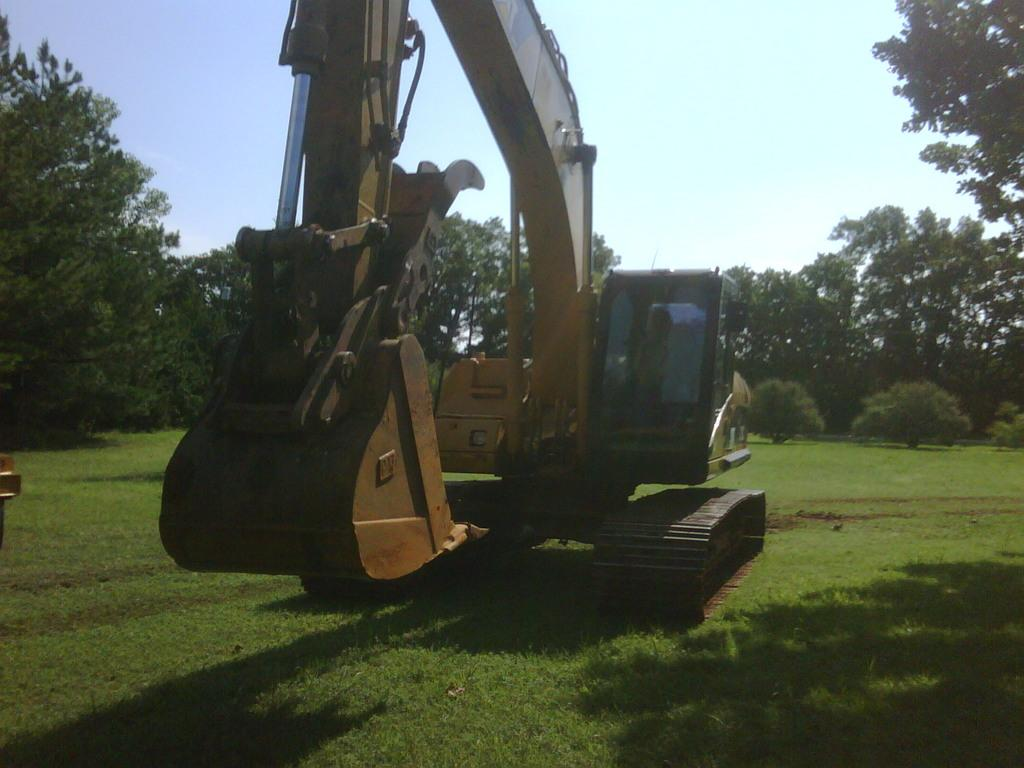What is the main subject in the image? There is a crane in the image. What can be seen on the ground in the image? The ground is visible in the image, and it has some grass. What type of vegetation is present in the image? There are plants and trees in the image. Can you describe the object on the left side of the image? Unfortunately, the facts provided do not give any information about the object on the left side of the image. What is visible in the sky in the image? The sky is visible in the image. What type of cloth is draped over the crane in the image? There is: There is no cloth draped over the crane in the image. 